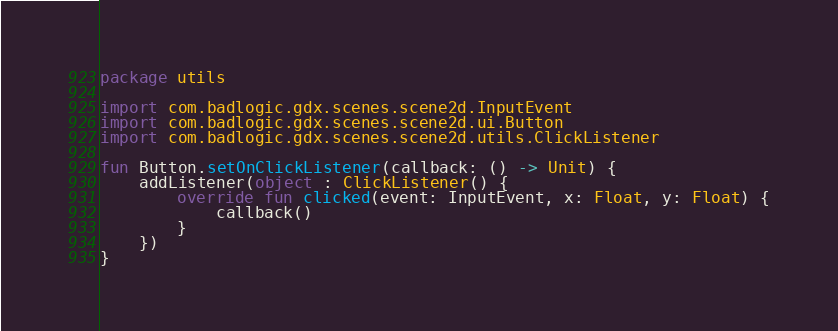Convert code to text. <code><loc_0><loc_0><loc_500><loc_500><_Kotlin_>package utils

import com.badlogic.gdx.scenes.scene2d.InputEvent
import com.badlogic.gdx.scenes.scene2d.ui.Button
import com.badlogic.gdx.scenes.scene2d.utils.ClickListener

fun Button.setOnClickListener(callback: () -> Unit) {
    addListener(object : ClickListener() {
        override fun clicked(event: InputEvent, x: Float, y: Float) {
            callback()
        }
    })
}</code> 